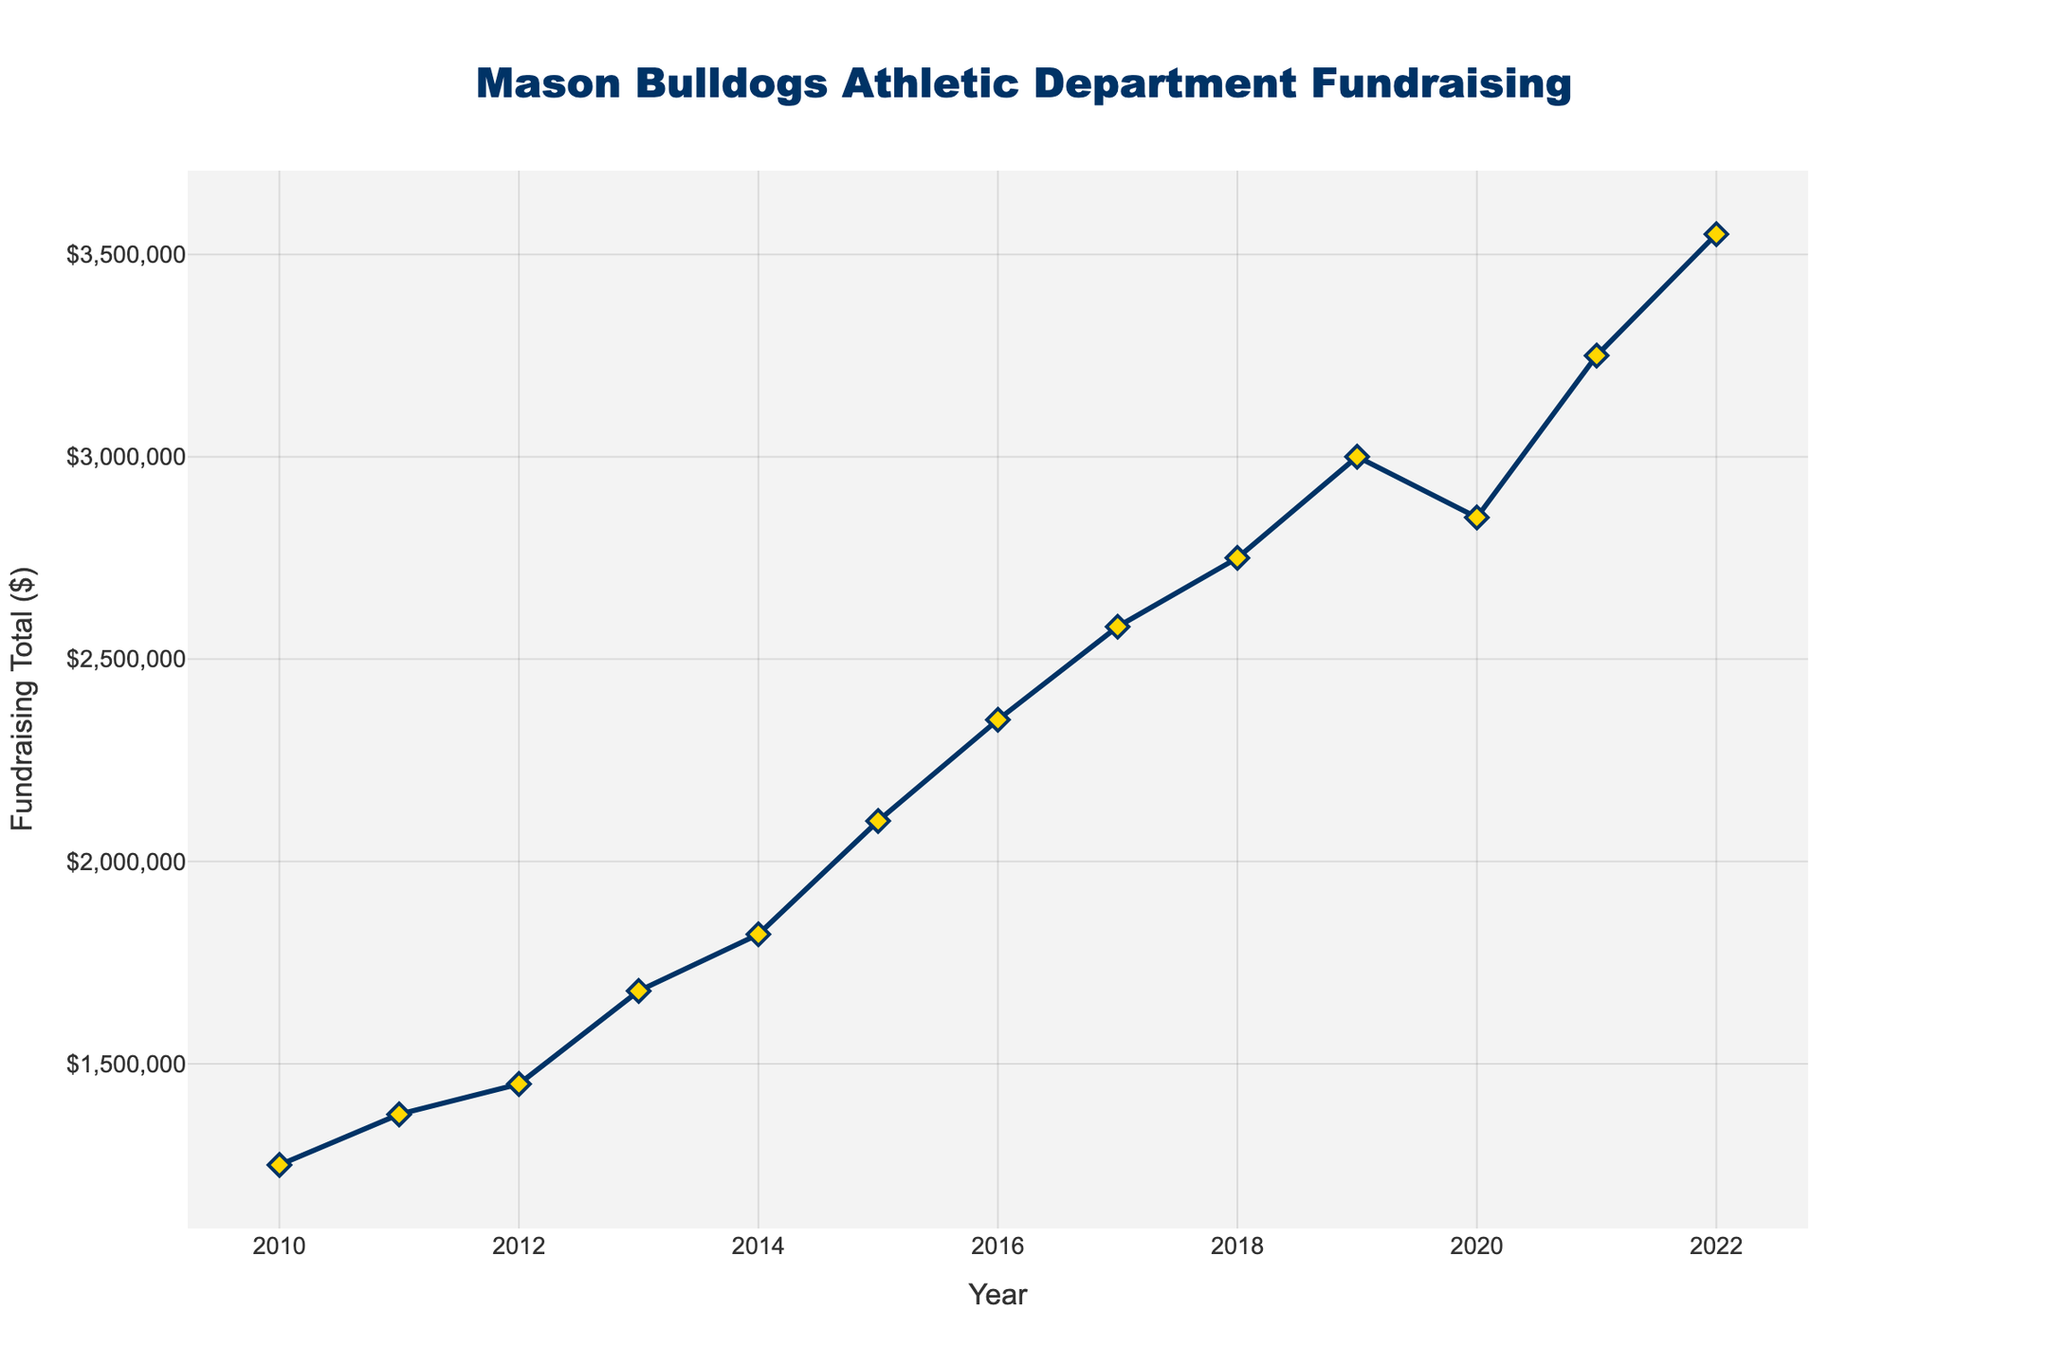What was the fundraising total in 2022? From the plot, locate the point corresponding to the year 2022 and read its value on the y-axis.
Answer: 3,550,000 In which year did the Mason Bulldogs athletic department see the highest fundraising total? Look for the highest peak on the fundraising line and note the corresponding year on the x-axis.
Answer: 2022 How much did the fundraising total increase from 2010 to 2015? Subtract the fundraising total in 2010 from the total in 2015. (2,100,000 - 1,250,000)
Answer: 850,000 In which year did the fundraising total decrease the most compared to the previous year? Identify the year where the drop between two consecutive points is the highest. From 2019 to 2020, the total decreased from 3,000,000 to 2,850,000.
Answer: 2020 What is the average fundraising total between 2010 and 2015? Sum the fundraising totals for the years 2010 to 2015 and then divide by the number of years (6). ((1,250,000 + 1,375,000 + 1,450,000 + 1,680,000 + 1,820,000 + 2,100,000) / 6)
Answer: 1,612,500 What is the percentage increase in fundraising totals from 2011 to 2012? Subtract the total in 2011 from the total in 2012, divide by the 2011 total, and multiply by 100. ((1,450,000 - 1,375,000) / 1,375,000) * 100
Answer: 5.45% In which years did the fundraising total surpass 2,500,000? Identify the years on the x-axis where the y-values exceed 2,500,000.
Answer: 2017, 2018, 2019, 2021, 2022 Compare the fundraising totals in 2018 and 2020. Which year had a higher total? Find the totals for 2018 and 2020 on the y-axis and compare them.
Answer: 2018 By how much did the fundraising total increase from 2015 to 2019? Subtract the fundraising total in 2015 from the total in 2019. (3,000,000 - 2,100,000)
Answer: 900,000 Was there any year where the fundraising total remained the same as the previous year? Check if there are any consecutive years with the same y-values.
Answer: No 